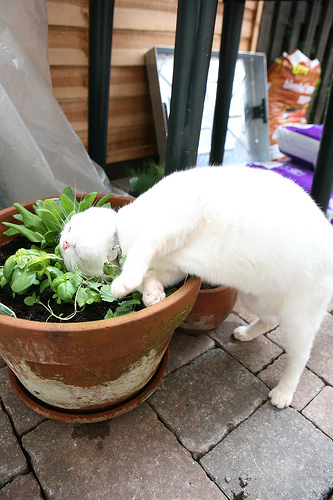Imagine a conversation between the cat and the plant. What might they say to each other? Cat: 'Hello, green friend! What makes you so interesting?' Plant: 'I am full of life and fragrance. Do you want to be my friend?' Cat: 'Maybe, but first, I must sniff and understand you better!' Plant: 'Go ahead, just be gentle with my leaves!' 